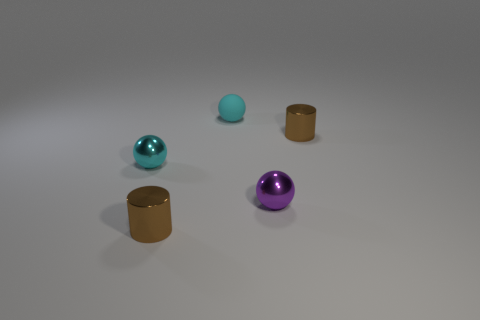Add 1 tiny shiny things. How many objects exist? 6 Subtract all balls. How many objects are left? 2 Subtract all cyan things. Subtract all tiny purple shiny things. How many objects are left? 2 Add 2 cyan shiny objects. How many cyan shiny objects are left? 3 Add 1 brown metal cylinders. How many brown metal cylinders exist? 3 Subtract 0 green cylinders. How many objects are left? 5 